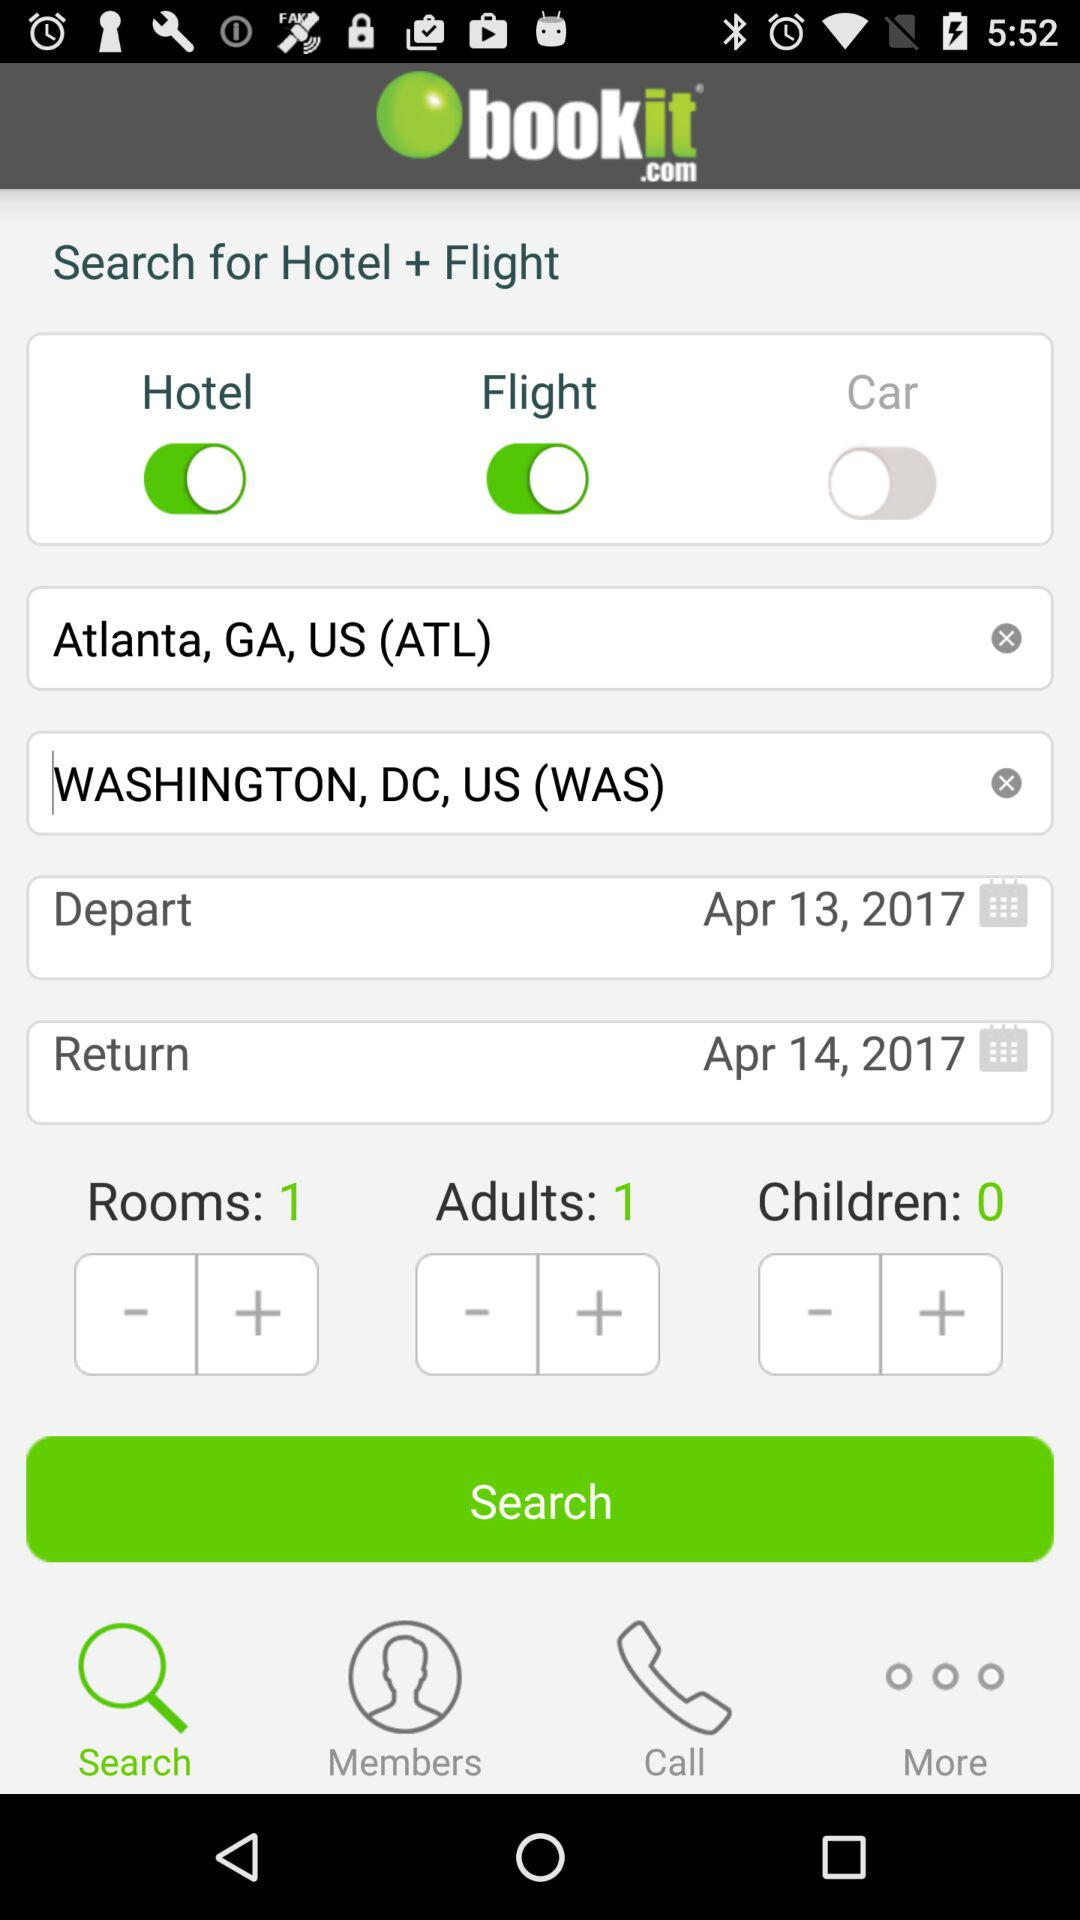What is the departure date? The departure date is April 13, 2017. 